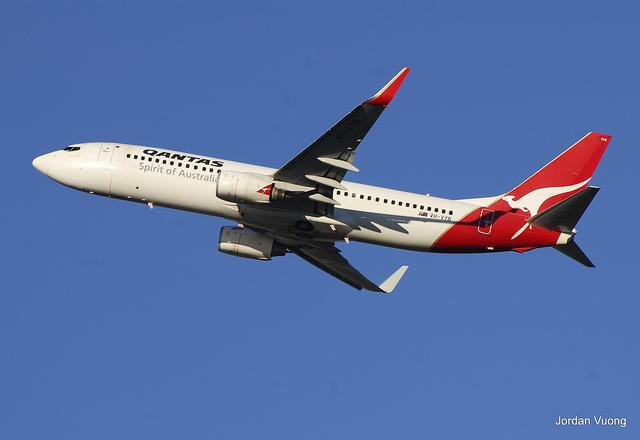Is the plane in flight?
Answer briefly. Yes. What is the name of the plane?
Short answer required. Qantas. Is this an Australian plane?
Concise answer only. Yes. What colors are on the tail of the plane?
Give a very brief answer. Red and white. What colors are on the plane?
Quick response, please. White and red. Is the plane landing?
Give a very brief answer. No. 